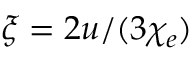<formula> <loc_0><loc_0><loc_500><loc_500>\xi = 2 u / ( 3 \chi _ { e } )</formula> 